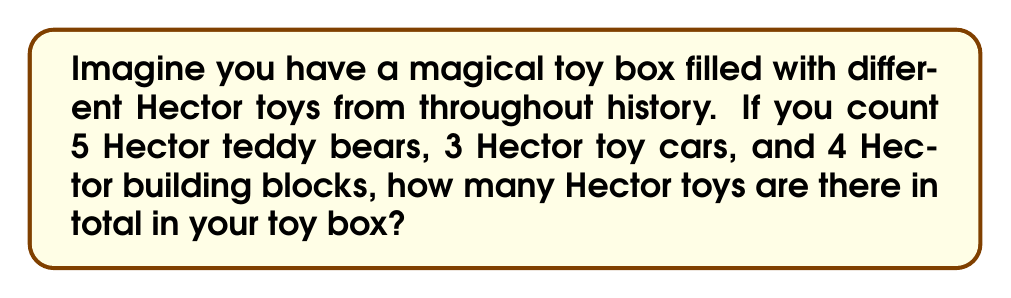Give your solution to this math problem. Let's count the Hector toys step by step:

1. First, we have 5 Hector teddy bears.
2. Then, we have 3 Hector toy cars.
3. Finally, we have 4 Hector building blocks.

To find the total number of Hector toys, we need to add all these together:

$$ \text{Total Hector toys} = \text{Teddy bears} + \text{Toy cars} + \text{Building blocks} $$

Let's substitute the numbers:

$$ \text{Total Hector toys} = 5 + 3 + 4 $$

Now, let's perform the addition:

$$ \text{Total Hector toys} = 12 $$

So, there are 12 Hector toys in total in your magical toy box.
Answer: 12 Hector toys 